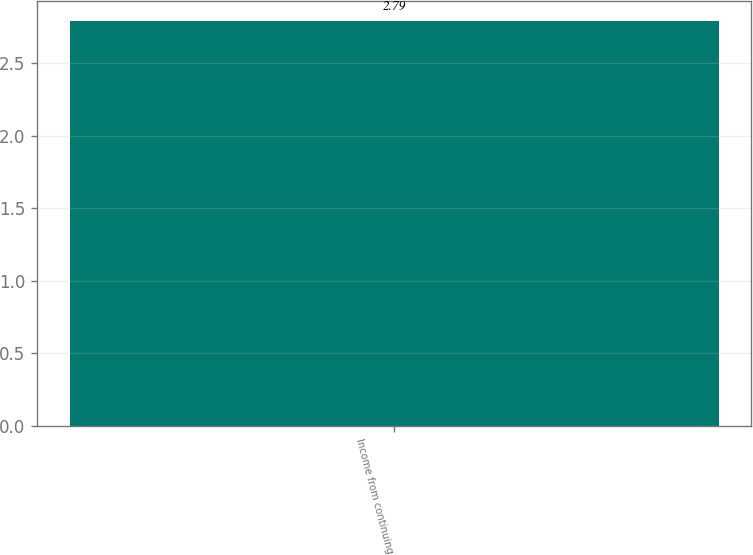Convert chart. <chart><loc_0><loc_0><loc_500><loc_500><bar_chart><fcel>Income from continuing<nl><fcel>2.79<nl></chart> 